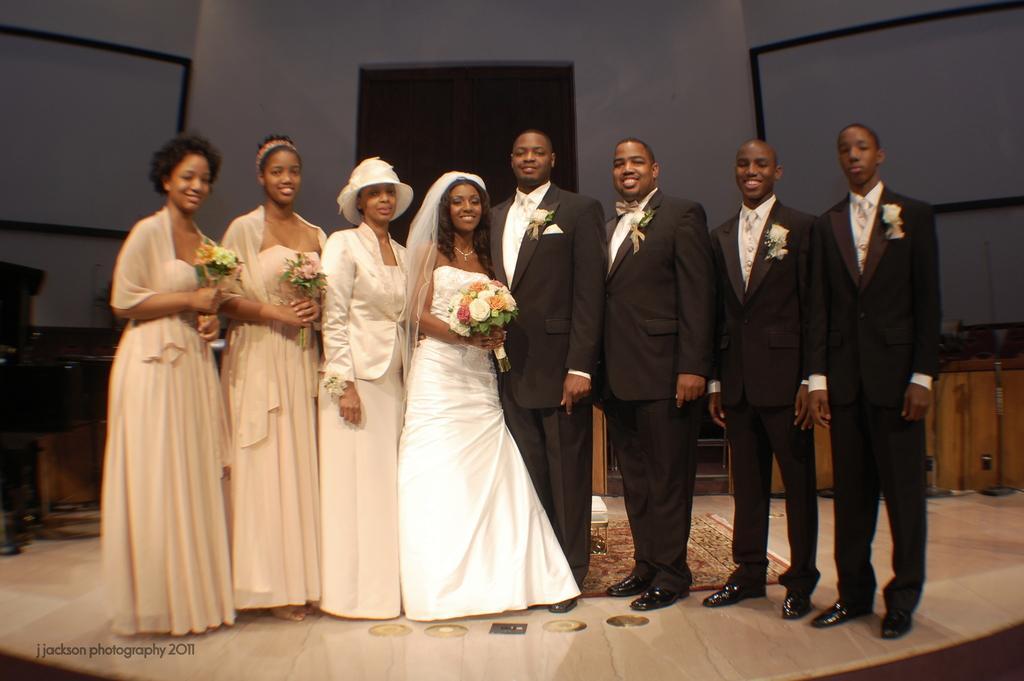Can you describe this image briefly? This picture describes about group of people, few people wore black color suits and few people holding bouquets, in the background we can see few projector screens, at the left bottom of the image we can see a watermark. 